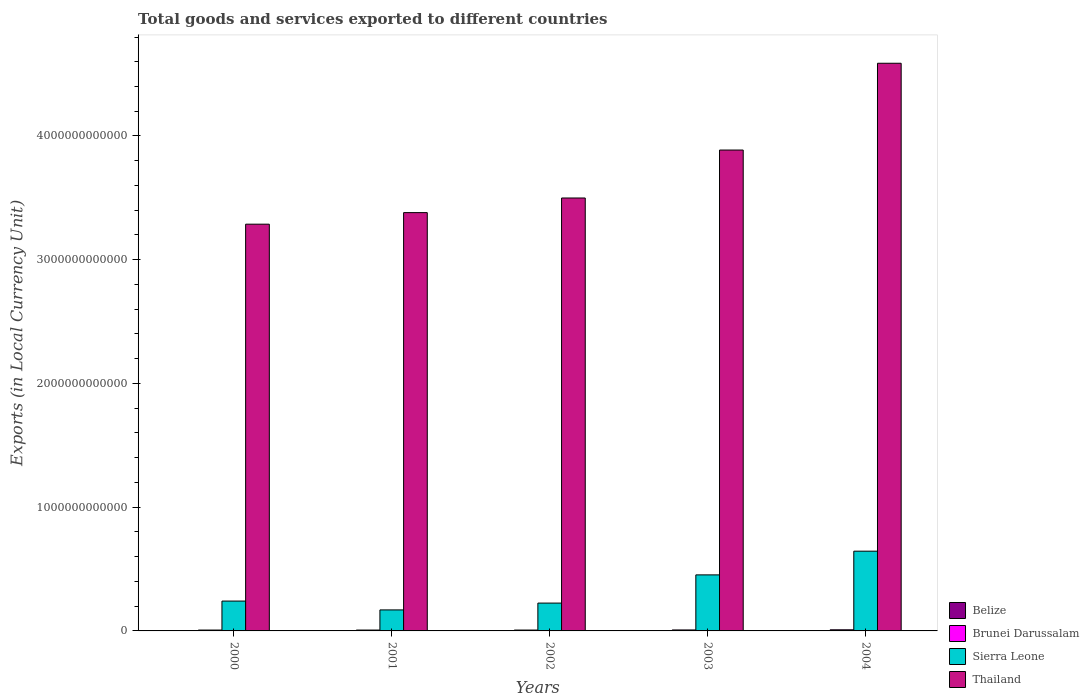How many groups of bars are there?
Give a very brief answer. 5. In how many cases, is the number of bars for a given year not equal to the number of legend labels?
Offer a terse response. 0. What is the Amount of goods and services exports in Belize in 2002?
Keep it short and to the point. 9.80e+08. Across all years, what is the maximum Amount of goods and services exports in Thailand?
Give a very brief answer. 4.59e+12. Across all years, what is the minimum Amount of goods and services exports in Brunei Darussalam?
Provide a succinct answer. 6.97e+09. What is the total Amount of goods and services exports in Brunei Darussalam in the graph?
Ensure brevity in your answer.  3.80e+1. What is the difference between the Amount of goods and services exports in Thailand in 2002 and that in 2003?
Your response must be concise. -3.88e+11. What is the difference between the Amount of goods and services exports in Thailand in 2000 and the Amount of goods and services exports in Brunei Darussalam in 2002?
Ensure brevity in your answer.  3.28e+12. What is the average Amount of goods and services exports in Thailand per year?
Make the answer very short. 3.73e+12. In the year 2002, what is the difference between the Amount of goods and services exports in Thailand and Amount of goods and services exports in Brunei Darussalam?
Offer a terse response. 3.49e+12. In how many years, is the Amount of goods and services exports in Belize greater than 400000000000 LCU?
Provide a short and direct response. 0. What is the ratio of the Amount of goods and services exports in Sierra Leone in 2000 to that in 2002?
Provide a short and direct response. 1.07. Is the difference between the Amount of goods and services exports in Thailand in 2000 and 2001 greater than the difference between the Amount of goods and services exports in Brunei Darussalam in 2000 and 2001?
Your answer should be very brief. No. What is the difference between the highest and the second highest Amount of goods and services exports in Belize?
Your response must be concise. 1.62e+07. What is the difference between the highest and the lowest Amount of goods and services exports in Sierra Leone?
Your response must be concise. 4.75e+11. Is it the case that in every year, the sum of the Amount of goods and services exports in Brunei Darussalam and Amount of goods and services exports in Belize is greater than the sum of Amount of goods and services exports in Sierra Leone and Amount of goods and services exports in Thailand?
Provide a succinct answer. No. What does the 3rd bar from the left in 2004 represents?
Give a very brief answer. Sierra Leone. What does the 3rd bar from the right in 2000 represents?
Your response must be concise. Brunei Darussalam. Is it the case that in every year, the sum of the Amount of goods and services exports in Belize and Amount of goods and services exports in Thailand is greater than the Amount of goods and services exports in Sierra Leone?
Offer a very short reply. Yes. Are all the bars in the graph horizontal?
Give a very brief answer. No. What is the difference between two consecutive major ticks on the Y-axis?
Your answer should be very brief. 1.00e+12. Are the values on the major ticks of Y-axis written in scientific E-notation?
Your answer should be compact. No. Does the graph contain any zero values?
Provide a succinct answer. No. Does the graph contain grids?
Offer a terse response. No. How many legend labels are there?
Keep it short and to the point. 4. What is the title of the graph?
Offer a very short reply. Total goods and services exported to different countries. What is the label or title of the Y-axis?
Keep it short and to the point. Exports (in Local Currency Unit). What is the Exports (in Local Currency Unit) of Belize in 2000?
Provide a succinct answer. 8.82e+08. What is the Exports (in Local Currency Unit) of Brunei Darussalam in 2000?
Offer a very short reply. 6.97e+09. What is the Exports (in Local Currency Unit) of Sierra Leone in 2000?
Give a very brief answer. 2.41e+11. What is the Exports (in Local Currency Unit) of Thailand in 2000?
Offer a terse response. 3.29e+12. What is the Exports (in Local Currency Unit) in Belize in 2001?
Your answer should be very brief. 8.87e+08. What is the Exports (in Local Currency Unit) of Brunei Darussalam in 2001?
Ensure brevity in your answer.  6.98e+09. What is the Exports (in Local Currency Unit) of Sierra Leone in 2001?
Offer a very short reply. 1.70e+11. What is the Exports (in Local Currency Unit) of Thailand in 2001?
Provide a succinct answer. 3.38e+12. What is the Exports (in Local Currency Unit) in Belize in 2002?
Offer a terse response. 9.80e+08. What is the Exports (in Local Currency Unit) of Brunei Darussalam in 2002?
Give a very brief answer. 7.02e+09. What is the Exports (in Local Currency Unit) in Sierra Leone in 2002?
Give a very brief answer. 2.25e+11. What is the Exports (in Local Currency Unit) of Thailand in 2002?
Provide a short and direct response. 3.50e+12. What is the Exports (in Local Currency Unit) in Belize in 2003?
Give a very brief answer. 1.05e+09. What is the Exports (in Local Currency Unit) in Brunei Darussalam in 2003?
Make the answer very short. 7.92e+09. What is the Exports (in Local Currency Unit) of Sierra Leone in 2003?
Offer a very short reply. 4.53e+11. What is the Exports (in Local Currency Unit) of Thailand in 2003?
Give a very brief answer. 3.89e+12. What is the Exports (in Local Currency Unit) in Belize in 2004?
Ensure brevity in your answer.  1.07e+09. What is the Exports (in Local Currency Unit) in Brunei Darussalam in 2004?
Provide a succinct answer. 9.15e+09. What is the Exports (in Local Currency Unit) in Sierra Leone in 2004?
Offer a very short reply. 6.44e+11. What is the Exports (in Local Currency Unit) in Thailand in 2004?
Make the answer very short. 4.59e+12. Across all years, what is the maximum Exports (in Local Currency Unit) of Belize?
Give a very brief answer. 1.07e+09. Across all years, what is the maximum Exports (in Local Currency Unit) of Brunei Darussalam?
Ensure brevity in your answer.  9.15e+09. Across all years, what is the maximum Exports (in Local Currency Unit) in Sierra Leone?
Offer a terse response. 6.44e+11. Across all years, what is the maximum Exports (in Local Currency Unit) in Thailand?
Offer a terse response. 4.59e+12. Across all years, what is the minimum Exports (in Local Currency Unit) of Belize?
Keep it short and to the point. 8.82e+08. Across all years, what is the minimum Exports (in Local Currency Unit) of Brunei Darussalam?
Ensure brevity in your answer.  6.97e+09. Across all years, what is the minimum Exports (in Local Currency Unit) of Sierra Leone?
Keep it short and to the point. 1.70e+11. Across all years, what is the minimum Exports (in Local Currency Unit) in Thailand?
Make the answer very short. 3.29e+12. What is the total Exports (in Local Currency Unit) of Belize in the graph?
Keep it short and to the point. 4.87e+09. What is the total Exports (in Local Currency Unit) of Brunei Darussalam in the graph?
Your answer should be very brief. 3.80e+1. What is the total Exports (in Local Currency Unit) in Sierra Leone in the graph?
Provide a succinct answer. 1.73e+12. What is the total Exports (in Local Currency Unit) of Thailand in the graph?
Keep it short and to the point. 1.86e+13. What is the difference between the Exports (in Local Currency Unit) of Belize in 2000 and that in 2001?
Provide a short and direct response. -5.50e+06. What is the difference between the Exports (in Local Currency Unit) of Brunei Darussalam in 2000 and that in 2001?
Ensure brevity in your answer.  -8.72e+06. What is the difference between the Exports (in Local Currency Unit) of Sierra Leone in 2000 and that in 2001?
Make the answer very short. 7.14e+1. What is the difference between the Exports (in Local Currency Unit) in Thailand in 2000 and that in 2001?
Offer a terse response. -9.35e+1. What is the difference between the Exports (in Local Currency Unit) in Belize in 2000 and that in 2002?
Your answer should be compact. -9.88e+07. What is the difference between the Exports (in Local Currency Unit) of Brunei Darussalam in 2000 and that in 2002?
Offer a terse response. -5.45e+07. What is the difference between the Exports (in Local Currency Unit) in Sierra Leone in 2000 and that in 2002?
Your answer should be compact. 1.63e+1. What is the difference between the Exports (in Local Currency Unit) in Thailand in 2000 and that in 2002?
Your answer should be compact. -2.12e+11. What is the difference between the Exports (in Local Currency Unit) of Belize in 2000 and that in 2003?
Provide a succinct answer. -1.72e+08. What is the difference between the Exports (in Local Currency Unit) of Brunei Darussalam in 2000 and that in 2003?
Your response must be concise. -9.47e+08. What is the difference between the Exports (in Local Currency Unit) of Sierra Leone in 2000 and that in 2003?
Provide a succinct answer. -2.12e+11. What is the difference between the Exports (in Local Currency Unit) of Thailand in 2000 and that in 2003?
Ensure brevity in your answer.  -5.99e+11. What is the difference between the Exports (in Local Currency Unit) of Belize in 2000 and that in 2004?
Give a very brief answer. -1.88e+08. What is the difference between the Exports (in Local Currency Unit) in Brunei Darussalam in 2000 and that in 2004?
Ensure brevity in your answer.  -2.19e+09. What is the difference between the Exports (in Local Currency Unit) in Sierra Leone in 2000 and that in 2004?
Make the answer very short. -4.03e+11. What is the difference between the Exports (in Local Currency Unit) in Thailand in 2000 and that in 2004?
Offer a very short reply. -1.30e+12. What is the difference between the Exports (in Local Currency Unit) of Belize in 2001 and that in 2002?
Your response must be concise. -9.33e+07. What is the difference between the Exports (in Local Currency Unit) in Brunei Darussalam in 2001 and that in 2002?
Provide a short and direct response. -4.58e+07. What is the difference between the Exports (in Local Currency Unit) in Sierra Leone in 2001 and that in 2002?
Provide a succinct answer. -5.51e+1. What is the difference between the Exports (in Local Currency Unit) in Thailand in 2001 and that in 2002?
Offer a very short reply. -1.18e+11. What is the difference between the Exports (in Local Currency Unit) of Belize in 2001 and that in 2003?
Your response must be concise. -1.66e+08. What is the difference between the Exports (in Local Currency Unit) in Brunei Darussalam in 2001 and that in 2003?
Keep it short and to the point. -9.39e+08. What is the difference between the Exports (in Local Currency Unit) of Sierra Leone in 2001 and that in 2003?
Ensure brevity in your answer.  -2.83e+11. What is the difference between the Exports (in Local Currency Unit) in Thailand in 2001 and that in 2003?
Your answer should be very brief. -5.06e+11. What is the difference between the Exports (in Local Currency Unit) of Belize in 2001 and that in 2004?
Keep it short and to the point. -1.83e+08. What is the difference between the Exports (in Local Currency Unit) in Brunei Darussalam in 2001 and that in 2004?
Ensure brevity in your answer.  -2.18e+09. What is the difference between the Exports (in Local Currency Unit) of Sierra Leone in 2001 and that in 2004?
Provide a succinct answer. -4.75e+11. What is the difference between the Exports (in Local Currency Unit) of Thailand in 2001 and that in 2004?
Make the answer very short. -1.21e+12. What is the difference between the Exports (in Local Currency Unit) in Belize in 2002 and that in 2003?
Your answer should be very brief. -7.32e+07. What is the difference between the Exports (in Local Currency Unit) of Brunei Darussalam in 2002 and that in 2003?
Ensure brevity in your answer.  -8.93e+08. What is the difference between the Exports (in Local Currency Unit) in Sierra Leone in 2002 and that in 2003?
Offer a very short reply. -2.28e+11. What is the difference between the Exports (in Local Currency Unit) of Thailand in 2002 and that in 2003?
Ensure brevity in your answer.  -3.88e+11. What is the difference between the Exports (in Local Currency Unit) of Belize in 2002 and that in 2004?
Offer a very short reply. -8.94e+07. What is the difference between the Exports (in Local Currency Unit) in Brunei Darussalam in 2002 and that in 2004?
Make the answer very short. -2.13e+09. What is the difference between the Exports (in Local Currency Unit) in Sierra Leone in 2002 and that in 2004?
Your response must be concise. -4.20e+11. What is the difference between the Exports (in Local Currency Unit) of Thailand in 2002 and that in 2004?
Offer a very short reply. -1.09e+12. What is the difference between the Exports (in Local Currency Unit) of Belize in 2003 and that in 2004?
Offer a very short reply. -1.62e+07. What is the difference between the Exports (in Local Currency Unit) of Brunei Darussalam in 2003 and that in 2004?
Offer a very short reply. -1.24e+09. What is the difference between the Exports (in Local Currency Unit) of Sierra Leone in 2003 and that in 2004?
Give a very brief answer. -1.92e+11. What is the difference between the Exports (in Local Currency Unit) of Thailand in 2003 and that in 2004?
Offer a very short reply. -7.01e+11. What is the difference between the Exports (in Local Currency Unit) in Belize in 2000 and the Exports (in Local Currency Unit) in Brunei Darussalam in 2001?
Keep it short and to the point. -6.10e+09. What is the difference between the Exports (in Local Currency Unit) of Belize in 2000 and the Exports (in Local Currency Unit) of Sierra Leone in 2001?
Your response must be concise. -1.69e+11. What is the difference between the Exports (in Local Currency Unit) in Belize in 2000 and the Exports (in Local Currency Unit) in Thailand in 2001?
Keep it short and to the point. -3.38e+12. What is the difference between the Exports (in Local Currency Unit) in Brunei Darussalam in 2000 and the Exports (in Local Currency Unit) in Sierra Leone in 2001?
Keep it short and to the point. -1.63e+11. What is the difference between the Exports (in Local Currency Unit) of Brunei Darussalam in 2000 and the Exports (in Local Currency Unit) of Thailand in 2001?
Offer a terse response. -3.37e+12. What is the difference between the Exports (in Local Currency Unit) of Sierra Leone in 2000 and the Exports (in Local Currency Unit) of Thailand in 2001?
Your answer should be compact. -3.14e+12. What is the difference between the Exports (in Local Currency Unit) in Belize in 2000 and the Exports (in Local Currency Unit) in Brunei Darussalam in 2002?
Ensure brevity in your answer.  -6.14e+09. What is the difference between the Exports (in Local Currency Unit) in Belize in 2000 and the Exports (in Local Currency Unit) in Sierra Leone in 2002?
Offer a very short reply. -2.24e+11. What is the difference between the Exports (in Local Currency Unit) in Belize in 2000 and the Exports (in Local Currency Unit) in Thailand in 2002?
Give a very brief answer. -3.50e+12. What is the difference between the Exports (in Local Currency Unit) in Brunei Darussalam in 2000 and the Exports (in Local Currency Unit) in Sierra Leone in 2002?
Provide a short and direct response. -2.18e+11. What is the difference between the Exports (in Local Currency Unit) in Brunei Darussalam in 2000 and the Exports (in Local Currency Unit) in Thailand in 2002?
Make the answer very short. -3.49e+12. What is the difference between the Exports (in Local Currency Unit) of Sierra Leone in 2000 and the Exports (in Local Currency Unit) of Thailand in 2002?
Your response must be concise. -3.26e+12. What is the difference between the Exports (in Local Currency Unit) of Belize in 2000 and the Exports (in Local Currency Unit) of Brunei Darussalam in 2003?
Make the answer very short. -7.03e+09. What is the difference between the Exports (in Local Currency Unit) in Belize in 2000 and the Exports (in Local Currency Unit) in Sierra Leone in 2003?
Provide a short and direct response. -4.52e+11. What is the difference between the Exports (in Local Currency Unit) in Belize in 2000 and the Exports (in Local Currency Unit) in Thailand in 2003?
Ensure brevity in your answer.  -3.89e+12. What is the difference between the Exports (in Local Currency Unit) of Brunei Darussalam in 2000 and the Exports (in Local Currency Unit) of Sierra Leone in 2003?
Offer a terse response. -4.46e+11. What is the difference between the Exports (in Local Currency Unit) of Brunei Darussalam in 2000 and the Exports (in Local Currency Unit) of Thailand in 2003?
Offer a terse response. -3.88e+12. What is the difference between the Exports (in Local Currency Unit) in Sierra Leone in 2000 and the Exports (in Local Currency Unit) in Thailand in 2003?
Ensure brevity in your answer.  -3.65e+12. What is the difference between the Exports (in Local Currency Unit) in Belize in 2000 and the Exports (in Local Currency Unit) in Brunei Darussalam in 2004?
Your answer should be compact. -8.27e+09. What is the difference between the Exports (in Local Currency Unit) in Belize in 2000 and the Exports (in Local Currency Unit) in Sierra Leone in 2004?
Your answer should be very brief. -6.44e+11. What is the difference between the Exports (in Local Currency Unit) in Belize in 2000 and the Exports (in Local Currency Unit) in Thailand in 2004?
Provide a succinct answer. -4.59e+12. What is the difference between the Exports (in Local Currency Unit) in Brunei Darussalam in 2000 and the Exports (in Local Currency Unit) in Sierra Leone in 2004?
Give a very brief answer. -6.38e+11. What is the difference between the Exports (in Local Currency Unit) in Brunei Darussalam in 2000 and the Exports (in Local Currency Unit) in Thailand in 2004?
Give a very brief answer. -4.58e+12. What is the difference between the Exports (in Local Currency Unit) of Sierra Leone in 2000 and the Exports (in Local Currency Unit) of Thailand in 2004?
Your answer should be very brief. -4.35e+12. What is the difference between the Exports (in Local Currency Unit) of Belize in 2001 and the Exports (in Local Currency Unit) of Brunei Darussalam in 2002?
Offer a very short reply. -6.14e+09. What is the difference between the Exports (in Local Currency Unit) of Belize in 2001 and the Exports (in Local Currency Unit) of Sierra Leone in 2002?
Provide a succinct answer. -2.24e+11. What is the difference between the Exports (in Local Currency Unit) of Belize in 2001 and the Exports (in Local Currency Unit) of Thailand in 2002?
Make the answer very short. -3.50e+12. What is the difference between the Exports (in Local Currency Unit) in Brunei Darussalam in 2001 and the Exports (in Local Currency Unit) in Sierra Leone in 2002?
Keep it short and to the point. -2.18e+11. What is the difference between the Exports (in Local Currency Unit) in Brunei Darussalam in 2001 and the Exports (in Local Currency Unit) in Thailand in 2002?
Keep it short and to the point. -3.49e+12. What is the difference between the Exports (in Local Currency Unit) in Sierra Leone in 2001 and the Exports (in Local Currency Unit) in Thailand in 2002?
Keep it short and to the point. -3.33e+12. What is the difference between the Exports (in Local Currency Unit) of Belize in 2001 and the Exports (in Local Currency Unit) of Brunei Darussalam in 2003?
Make the answer very short. -7.03e+09. What is the difference between the Exports (in Local Currency Unit) of Belize in 2001 and the Exports (in Local Currency Unit) of Sierra Leone in 2003?
Ensure brevity in your answer.  -4.52e+11. What is the difference between the Exports (in Local Currency Unit) in Belize in 2001 and the Exports (in Local Currency Unit) in Thailand in 2003?
Your response must be concise. -3.89e+12. What is the difference between the Exports (in Local Currency Unit) of Brunei Darussalam in 2001 and the Exports (in Local Currency Unit) of Sierra Leone in 2003?
Your answer should be compact. -4.46e+11. What is the difference between the Exports (in Local Currency Unit) of Brunei Darussalam in 2001 and the Exports (in Local Currency Unit) of Thailand in 2003?
Offer a terse response. -3.88e+12. What is the difference between the Exports (in Local Currency Unit) in Sierra Leone in 2001 and the Exports (in Local Currency Unit) in Thailand in 2003?
Your answer should be compact. -3.72e+12. What is the difference between the Exports (in Local Currency Unit) in Belize in 2001 and the Exports (in Local Currency Unit) in Brunei Darussalam in 2004?
Ensure brevity in your answer.  -8.27e+09. What is the difference between the Exports (in Local Currency Unit) of Belize in 2001 and the Exports (in Local Currency Unit) of Sierra Leone in 2004?
Your response must be concise. -6.44e+11. What is the difference between the Exports (in Local Currency Unit) in Belize in 2001 and the Exports (in Local Currency Unit) in Thailand in 2004?
Your response must be concise. -4.59e+12. What is the difference between the Exports (in Local Currency Unit) of Brunei Darussalam in 2001 and the Exports (in Local Currency Unit) of Sierra Leone in 2004?
Your response must be concise. -6.38e+11. What is the difference between the Exports (in Local Currency Unit) in Brunei Darussalam in 2001 and the Exports (in Local Currency Unit) in Thailand in 2004?
Offer a terse response. -4.58e+12. What is the difference between the Exports (in Local Currency Unit) in Sierra Leone in 2001 and the Exports (in Local Currency Unit) in Thailand in 2004?
Your response must be concise. -4.42e+12. What is the difference between the Exports (in Local Currency Unit) of Belize in 2002 and the Exports (in Local Currency Unit) of Brunei Darussalam in 2003?
Offer a very short reply. -6.94e+09. What is the difference between the Exports (in Local Currency Unit) of Belize in 2002 and the Exports (in Local Currency Unit) of Sierra Leone in 2003?
Keep it short and to the point. -4.52e+11. What is the difference between the Exports (in Local Currency Unit) in Belize in 2002 and the Exports (in Local Currency Unit) in Thailand in 2003?
Give a very brief answer. -3.89e+12. What is the difference between the Exports (in Local Currency Unit) in Brunei Darussalam in 2002 and the Exports (in Local Currency Unit) in Sierra Leone in 2003?
Your response must be concise. -4.46e+11. What is the difference between the Exports (in Local Currency Unit) in Brunei Darussalam in 2002 and the Exports (in Local Currency Unit) in Thailand in 2003?
Make the answer very short. -3.88e+12. What is the difference between the Exports (in Local Currency Unit) of Sierra Leone in 2002 and the Exports (in Local Currency Unit) of Thailand in 2003?
Your answer should be compact. -3.66e+12. What is the difference between the Exports (in Local Currency Unit) of Belize in 2002 and the Exports (in Local Currency Unit) of Brunei Darussalam in 2004?
Ensure brevity in your answer.  -8.17e+09. What is the difference between the Exports (in Local Currency Unit) of Belize in 2002 and the Exports (in Local Currency Unit) of Sierra Leone in 2004?
Your response must be concise. -6.44e+11. What is the difference between the Exports (in Local Currency Unit) of Belize in 2002 and the Exports (in Local Currency Unit) of Thailand in 2004?
Your answer should be compact. -4.59e+12. What is the difference between the Exports (in Local Currency Unit) of Brunei Darussalam in 2002 and the Exports (in Local Currency Unit) of Sierra Leone in 2004?
Keep it short and to the point. -6.37e+11. What is the difference between the Exports (in Local Currency Unit) of Brunei Darussalam in 2002 and the Exports (in Local Currency Unit) of Thailand in 2004?
Provide a succinct answer. -4.58e+12. What is the difference between the Exports (in Local Currency Unit) of Sierra Leone in 2002 and the Exports (in Local Currency Unit) of Thailand in 2004?
Offer a very short reply. -4.36e+12. What is the difference between the Exports (in Local Currency Unit) of Belize in 2003 and the Exports (in Local Currency Unit) of Brunei Darussalam in 2004?
Your answer should be compact. -8.10e+09. What is the difference between the Exports (in Local Currency Unit) in Belize in 2003 and the Exports (in Local Currency Unit) in Sierra Leone in 2004?
Give a very brief answer. -6.43e+11. What is the difference between the Exports (in Local Currency Unit) in Belize in 2003 and the Exports (in Local Currency Unit) in Thailand in 2004?
Provide a short and direct response. -4.59e+12. What is the difference between the Exports (in Local Currency Unit) of Brunei Darussalam in 2003 and the Exports (in Local Currency Unit) of Sierra Leone in 2004?
Offer a terse response. -6.37e+11. What is the difference between the Exports (in Local Currency Unit) in Brunei Darussalam in 2003 and the Exports (in Local Currency Unit) in Thailand in 2004?
Offer a very short reply. -4.58e+12. What is the difference between the Exports (in Local Currency Unit) in Sierra Leone in 2003 and the Exports (in Local Currency Unit) in Thailand in 2004?
Give a very brief answer. -4.13e+12. What is the average Exports (in Local Currency Unit) of Belize per year?
Your answer should be very brief. 9.74e+08. What is the average Exports (in Local Currency Unit) of Brunei Darussalam per year?
Provide a short and direct response. 7.61e+09. What is the average Exports (in Local Currency Unit) of Sierra Leone per year?
Give a very brief answer. 3.47e+11. What is the average Exports (in Local Currency Unit) of Thailand per year?
Your answer should be compact. 3.73e+12. In the year 2000, what is the difference between the Exports (in Local Currency Unit) in Belize and Exports (in Local Currency Unit) in Brunei Darussalam?
Keep it short and to the point. -6.09e+09. In the year 2000, what is the difference between the Exports (in Local Currency Unit) in Belize and Exports (in Local Currency Unit) in Sierra Leone?
Keep it short and to the point. -2.40e+11. In the year 2000, what is the difference between the Exports (in Local Currency Unit) in Belize and Exports (in Local Currency Unit) in Thailand?
Your answer should be very brief. -3.29e+12. In the year 2000, what is the difference between the Exports (in Local Currency Unit) in Brunei Darussalam and Exports (in Local Currency Unit) in Sierra Leone?
Offer a very short reply. -2.34e+11. In the year 2000, what is the difference between the Exports (in Local Currency Unit) in Brunei Darussalam and Exports (in Local Currency Unit) in Thailand?
Offer a very short reply. -3.28e+12. In the year 2000, what is the difference between the Exports (in Local Currency Unit) of Sierra Leone and Exports (in Local Currency Unit) of Thailand?
Offer a terse response. -3.05e+12. In the year 2001, what is the difference between the Exports (in Local Currency Unit) in Belize and Exports (in Local Currency Unit) in Brunei Darussalam?
Your response must be concise. -6.09e+09. In the year 2001, what is the difference between the Exports (in Local Currency Unit) of Belize and Exports (in Local Currency Unit) of Sierra Leone?
Ensure brevity in your answer.  -1.69e+11. In the year 2001, what is the difference between the Exports (in Local Currency Unit) in Belize and Exports (in Local Currency Unit) in Thailand?
Keep it short and to the point. -3.38e+12. In the year 2001, what is the difference between the Exports (in Local Currency Unit) of Brunei Darussalam and Exports (in Local Currency Unit) of Sierra Leone?
Offer a terse response. -1.63e+11. In the year 2001, what is the difference between the Exports (in Local Currency Unit) in Brunei Darussalam and Exports (in Local Currency Unit) in Thailand?
Offer a very short reply. -3.37e+12. In the year 2001, what is the difference between the Exports (in Local Currency Unit) of Sierra Leone and Exports (in Local Currency Unit) of Thailand?
Make the answer very short. -3.21e+12. In the year 2002, what is the difference between the Exports (in Local Currency Unit) in Belize and Exports (in Local Currency Unit) in Brunei Darussalam?
Ensure brevity in your answer.  -6.04e+09. In the year 2002, what is the difference between the Exports (in Local Currency Unit) of Belize and Exports (in Local Currency Unit) of Sierra Leone?
Keep it short and to the point. -2.24e+11. In the year 2002, what is the difference between the Exports (in Local Currency Unit) of Belize and Exports (in Local Currency Unit) of Thailand?
Keep it short and to the point. -3.50e+12. In the year 2002, what is the difference between the Exports (in Local Currency Unit) in Brunei Darussalam and Exports (in Local Currency Unit) in Sierra Leone?
Provide a short and direct response. -2.18e+11. In the year 2002, what is the difference between the Exports (in Local Currency Unit) in Brunei Darussalam and Exports (in Local Currency Unit) in Thailand?
Make the answer very short. -3.49e+12. In the year 2002, what is the difference between the Exports (in Local Currency Unit) in Sierra Leone and Exports (in Local Currency Unit) in Thailand?
Your response must be concise. -3.27e+12. In the year 2003, what is the difference between the Exports (in Local Currency Unit) in Belize and Exports (in Local Currency Unit) in Brunei Darussalam?
Provide a succinct answer. -6.86e+09. In the year 2003, what is the difference between the Exports (in Local Currency Unit) of Belize and Exports (in Local Currency Unit) of Sierra Leone?
Your answer should be very brief. -4.52e+11. In the year 2003, what is the difference between the Exports (in Local Currency Unit) of Belize and Exports (in Local Currency Unit) of Thailand?
Provide a short and direct response. -3.89e+12. In the year 2003, what is the difference between the Exports (in Local Currency Unit) of Brunei Darussalam and Exports (in Local Currency Unit) of Sierra Leone?
Your response must be concise. -4.45e+11. In the year 2003, what is the difference between the Exports (in Local Currency Unit) in Brunei Darussalam and Exports (in Local Currency Unit) in Thailand?
Provide a succinct answer. -3.88e+12. In the year 2003, what is the difference between the Exports (in Local Currency Unit) of Sierra Leone and Exports (in Local Currency Unit) of Thailand?
Keep it short and to the point. -3.43e+12. In the year 2004, what is the difference between the Exports (in Local Currency Unit) in Belize and Exports (in Local Currency Unit) in Brunei Darussalam?
Keep it short and to the point. -8.08e+09. In the year 2004, what is the difference between the Exports (in Local Currency Unit) in Belize and Exports (in Local Currency Unit) in Sierra Leone?
Offer a very short reply. -6.43e+11. In the year 2004, what is the difference between the Exports (in Local Currency Unit) in Belize and Exports (in Local Currency Unit) in Thailand?
Give a very brief answer. -4.59e+12. In the year 2004, what is the difference between the Exports (in Local Currency Unit) of Brunei Darussalam and Exports (in Local Currency Unit) of Sierra Leone?
Ensure brevity in your answer.  -6.35e+11. In the year 2004, what is the difference between the Exports (in Local Currency Unit) in Brunei Darussalam and Exports (in Local Currency Unit) in Thailand?
Give a very brief answer. -4.58e+12. In the year 2004, what is the difference between the Exports (in Local Currency Unit) in Sierra Leone and Exports (in Local Currency Unit) in Thailand?
Your answer should be compact. -3.94e+12. What is the ratio of the Exports (in Local Currency Unit) of Belize in 2000 to that in 2001?
Ensure brevity in your answer.  0.99. What is the ratio of the Exports (in Local Currency Unit) of Sierra Leone in 2000 to that in 2001?
Offer a very short reply. 1.42. What is the ratio of the Exports (in Local Currency Unit) of Thailand in 2000 to that in 2001?
Offer a terse response. 0.97. What is the ratio of the Exports (in Local Currency Unit) of Belize in 2000 to that in 2002?
Offer a terse response. 0.9. What is the ratio of the Exports (in Local Currency Unit) of Sierra Leone in 2000 to that in 2002?
Provide a succinct answer. 1.07. What is the ratio of the Exports (in Local Currency Unit) in Thailand in 2000 to that in 2002?
Make the answer very short. 0.94. What is the ratio of the Exports (in Local Currency Unit) of Belize in 2000 to that in 2003?
Provide a short and direct response. 0.84. What is the ratio of the Exports (in Local Currency Unit) in Brunei Darussalam in 2000 to that in 2003?
Make the answer very short. 0.88. What is the ratio of the Exports (in Local Currency Unit) of Sierra Leone in 2000 to that in 2003?
Provide a succinct answer. 0.53. What is the ratio of the Exports (in Local Currency Unit) of Thailand in 2000 to that in 2003?
Your response must be concise. 0.85. What is the ratio of the Exports (in Local Currency Unit) of Belize in 2000 to that in 2004?
Make the answer very short. 0.82. What is the ratio of the Exports (in Local Currency Unit) in Brunei Darussalam in 2000 to that in 2004?
Your response must be concise. 0.76. What is the ratio of the Exports (in Local Currency Unit) in Sierra Leone in 2000 to that in 2004?
Give a very brief answer. 0.37. What is the ratio of the Exports (in Local Currency Unit) of Thailand in 2000 to that in 2004?
Provide a short and direct response. 0.72. What is the ratio of the Exports (in Local Currency Unit) of Belize in 2001 to that in 2002?
Offer a very short reply. 0.9. What is the ratio of the Exports (in Local Currency Unit) in Sierra Leone in 2001 to that in 2002?
Give a very brief answer. 0.76. What is the ratio of the Exports (in Local Currency Unit) of Thailand in 2001 to that in 2002?
Your answer should be very brief. 0.97. What is the ratio of the Exports (in Local Currency Unit) of Belize in 2001 to that in 2003?
Give a very brief answer. 0.84. What is the ratio of the Exports (in Local Currency Unit) of Brunei Darussalam in 2001 to that in 2003?
Provide a succinct answer. 0.88. What is the ratio of the Exports (in Local Currency Unit) of Sierra Leone in 2001 to that in 2003?
Your answer should be compact. 0.37. What is the ratio of the Exports (in Local Currency Unit) in Thailand in 2001 to that in 2003?
Offer a very short reply. 0.87. What is the ratio of the Exports (in Local Currency Unit) of Belize in 2001 to that in 2004?
Offer a terse response. 0.83. What is the ratio of the Exports (in Local Currency Unit) of Brunei Darussalam in 2001 to that in 2004?
Your response must be concise. 0.76. What is the ratio of the Exports (in Local Currency Unit) in Sierra Leone in 2001 to that in 2004?
Your answer should be very brief. 0.26. What is the ratio of the Exports (in Local Currency Unit) in Thailand in 2001 to that in 2004?
Your answer should be very brief. 0.74. What is the ratio of the Exports (in Local Currency Unit) of Belize in 2002 to that in 2003?
Provide a short and direct response. 0.93. What is the ratio of the Exports (in Local Currency Unit) in Brunei Darussalam in 2002 to that in 2003?
Your answer should be very brief. 0.89. What is the ratio of the Exports (in Local Currency Unit) in Sierra Leone in 2002 to that in 2003?
Your answer should be compact. 0.5. What is the ratio of the Exports (in Local Currency Unit) in Thailand in 2002 to that in 2003?
Offer a terse response. 0.9. What is the ratio of the Exports (in Local Currency Unit) of Belize in 2002 to that in 2004?
Make the answer very short. 0.92. What is the ratio of the Exports (in Local Currency Unit) in Brunei Darussalam in 2002 to that in 2004?
Provide a succinct answer. 0.77. What is the ratio of the Exports (in Local Currency Unit) in Sierra Leone in 2002 to that in 2004?
Offer a terse response. 0.35. What is the ratio of the Exports (in Local Currency Unit) of Thailand in 2002 to that in 2004?
Provide a short and direct response. 0.76. What is the ratio of the Exports (in Local Currency Unit) of Belize in 2003 to that in 2004?
Keep it short and to the point. 0.98. What is the ratio of the Exports (in Local Currency Unit) of Brunei Darussalam in 2003 to that in 2004?
Ensure brevity in your answer.  0.86. What is the ratio of the Exports (in Local Currency Unit) in Sierra Leone in 2003 to that in 2004?
Ensure brevity in your answer.  0.7. What is the ratio of the Exports (in Local Currency Unit) of Thailand in 2003 to that in 2004?
Give a very brief answer. 0.85. What is the difference between the highest and the second highest Exports (in Local Currency Unit) of Belize?
Your answer should be very brief. 1.62e+07. What is the difference between the highest and the second highest Exports (in Local Currency Unit) in Brunei Darussalam?
Provide a succinct answer. 1.24e+09. What is the difference between the highest and the second highest Exports (in Local Currency Unit) in Sierra Leone?
Your response must be concise. 1.92e+11. What is the difference between the highest and the second highest Exports (in Local Currency Unit) in Thailand?
Provide a short and direct response. 7.01e+11. What is the difference between the highest and the lowest Exports (in Local Currency Unit) in Belize?
Provide a succinct answer. 1.88e+08. What is the difference between the highest and the lowest Exports (in Local Currency Unit) of Brunei Darussalam?
Make the answer very short. 2.19e+09. What is the difference between the highest and the lowest Exports (in Local Currency Unit) of Sierra Leone?
Provide a short and direct response. 4.75e+11. What is the difference between the highest and the lowest Exports (in Local Currency Unit) of Thailand?
Your response must be concise. 1.30e+12. 